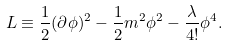<formula> <loc_0><loc_0><loc_500><loc_500>L \equiv \frac { 1 } { 2 } ( \partial \phi ) ^ { 2 } - \frac { 1 } { 2 } m ^ { 2 } \phi ^ { 2 } - \frac { \lambda } { 4 ! } \phi ^ { 4 } .</formula> 